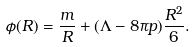<formula> <loc_0><loc_0><loc_500><loc_500>\phi ( R ) = \frac { m } { R } + ( \Lambda - 8 \pi p ) \frac { R ^ { 2 } } { 6 } .</formula> 